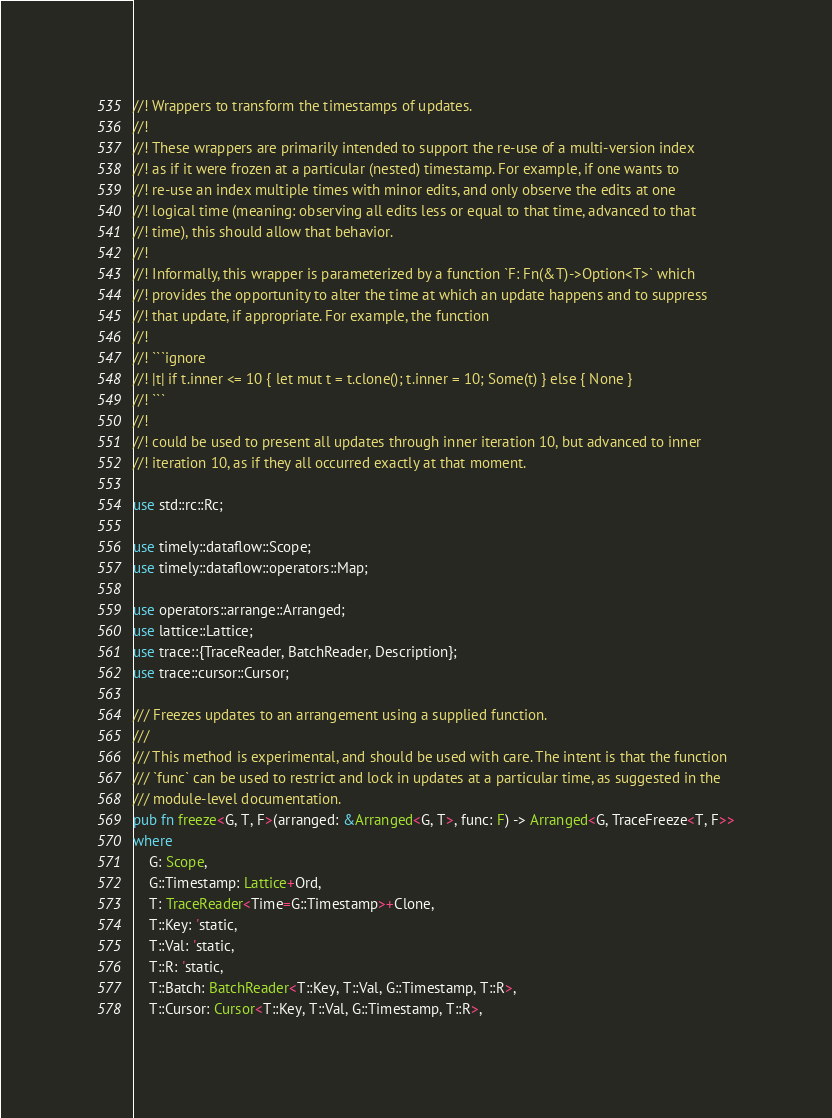Convert code to text. <code><loc_0><loc_0><loc_500><loc_500><_Rust_>//! Wrappers to transform the timestamps of updates.
//!
//! These wrappers are primarily intended to support the re-use of a multi-version index
//! as if it were frozen at a particular (nested) timestamp. For example, if one wants to
//! re-use an index multiple times with minor edits, and only observe the edits at one
//! logical time (meaning: observing all edits less or equal to that time, advanced to that
//! time), this should allow that behavior.
//!
//! Informally, this wrapper is parameterized by a function `F: Fn(&T)->Option<T>` which
//! provides the opportunity to alter the time at which an update happens and to suppress
//! that update, if appropriate. For example, the function
//!
//! ```ignore
//! |t| if t.inner <= 10 { let mut t = t.clone(); t.inner = 10; Some(t) } else { None }
//! ```
//!
//! could be used to present all updates through inner iteration 10, but advanced to inner
//! iteration 10, as if they all occurred exactly at that moment.

use std::rc::Rc;

use timely::dataflow::Scope;
use timely::dataflow::operators::Map;

use operators::arrange::Arranged;
use lattice::Lattice;
use trace::{TraceReader, BatchReader, Description};
use trace::cursor::Cursor;

/// Freezes updates to an arrangement using a supplied function.
///
/// This method is experimental, and should be used with care. The intent is that the function
/// `func` can be used to restrict and lock in updates at a particular time, as suggested in the
/// module-level documentation.
pub fn freeze<G, T, F>(arranged: &Arranged<G, T>, func: F) -> Arranged<G, TraceFreeze<T, F>>
where
    G: Scope,
    G::Timestamp: Lattice+Ord,
    T: TraceReader<Time=G::Timestamp>+Clone,
    T::Key: 'static,
    T::Val: 'static,
    T::R: 'static,
    T::Batch: BatchReader<T::Key, T::Val, G::Timestamp, T::R>,
    T::Cursor: Cursor<T::Key, T::Val, G::Timestamp, T::R>,</code> 